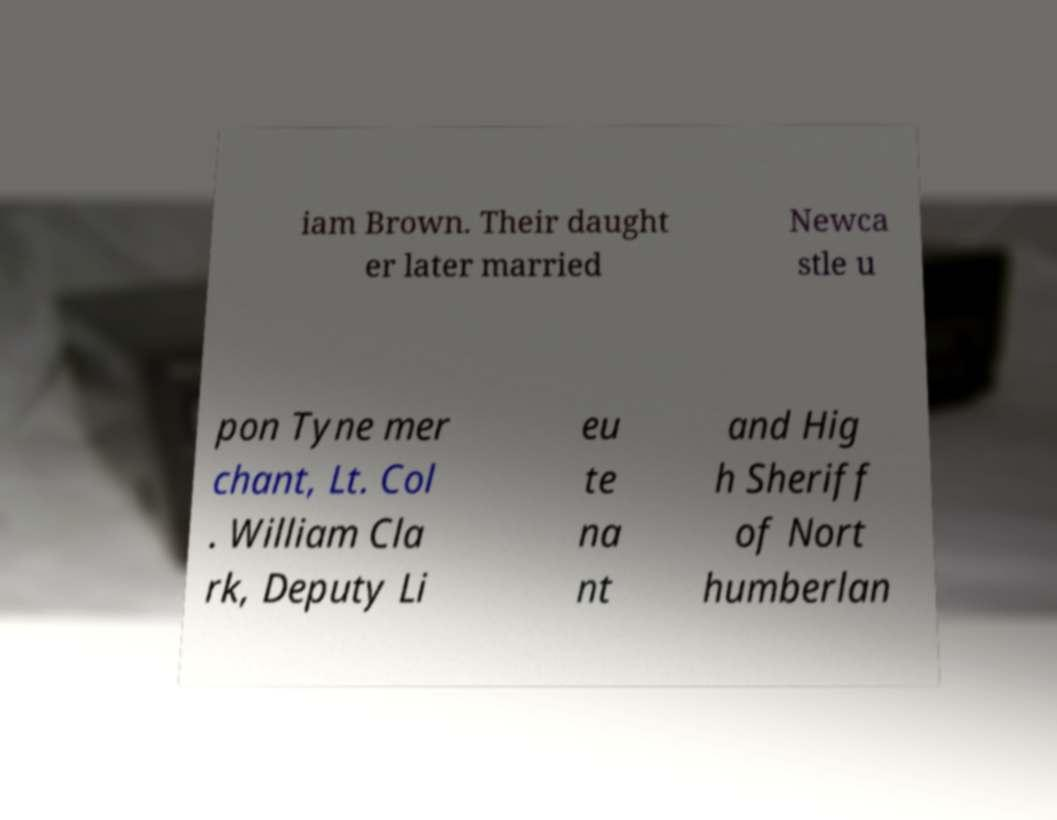Can you accurately transcribe the text from the provided image for me? iam Brown. Their daught er later married Newca stle u pon Tyne mer chant, Lt. Col . William Cla rk, Deputy Li eu te na nt and Hig h Sheriff of Nort humberlan 